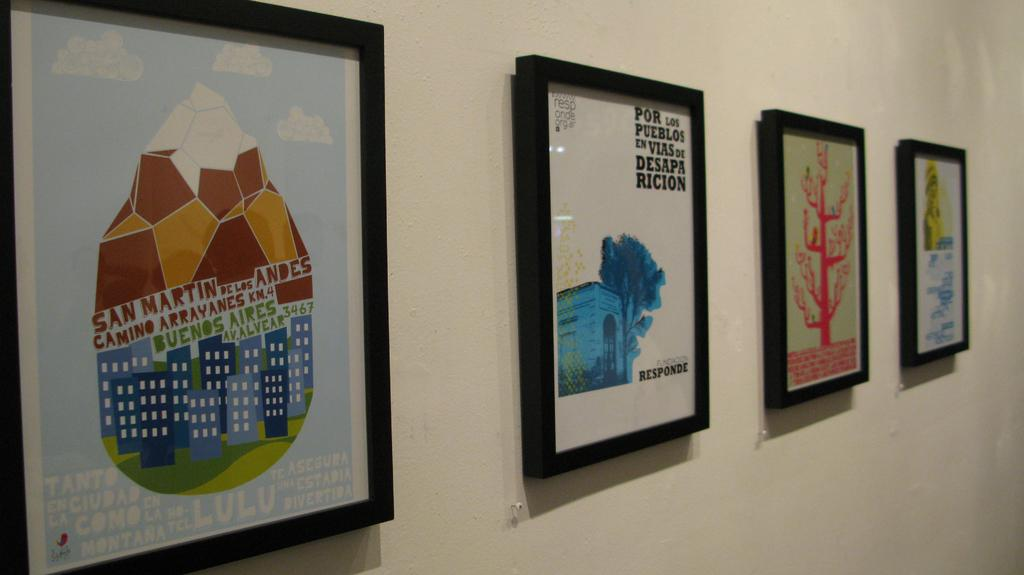<image>
Share a concise interpretation of the image provided. Four framed drawing are hanging on a white wall and one says, "San Martin" on it. 